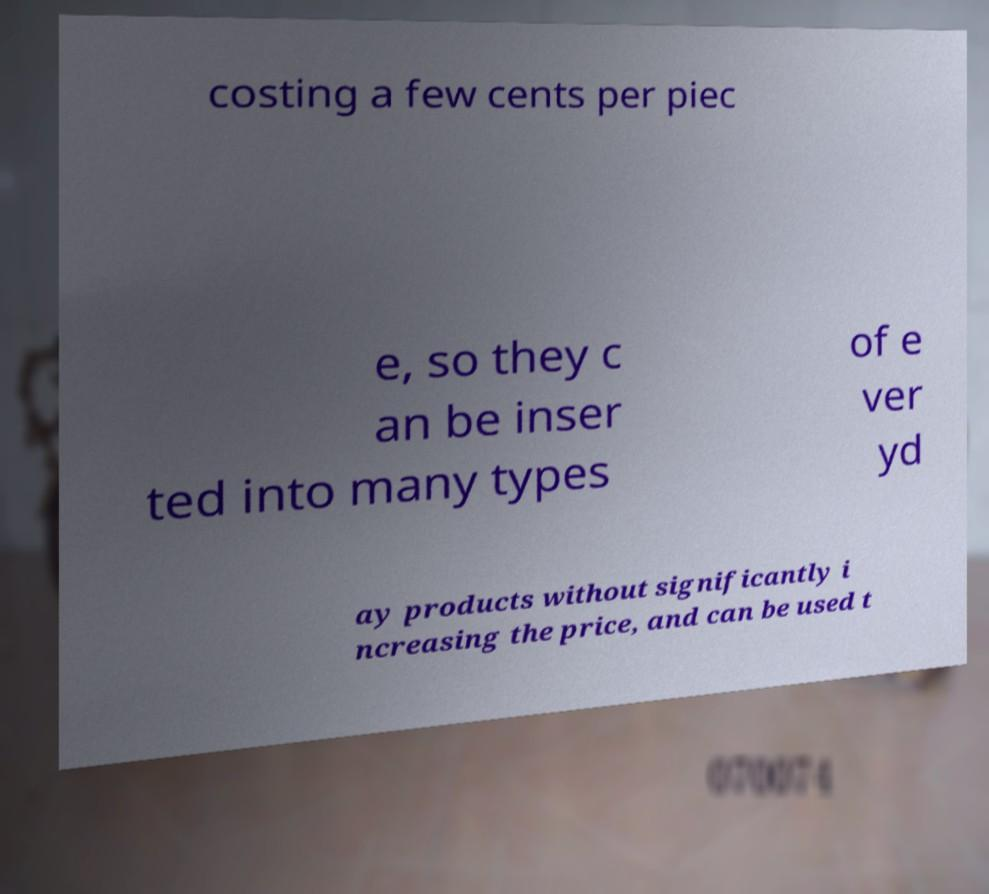For documentation purposes, I need the text within this image transcribed. Could you provide that? costing a few cents per piec e, so they c an be inser ted into many types of e ver yd ay products without significantly i ncreasing the price, and can be used t 